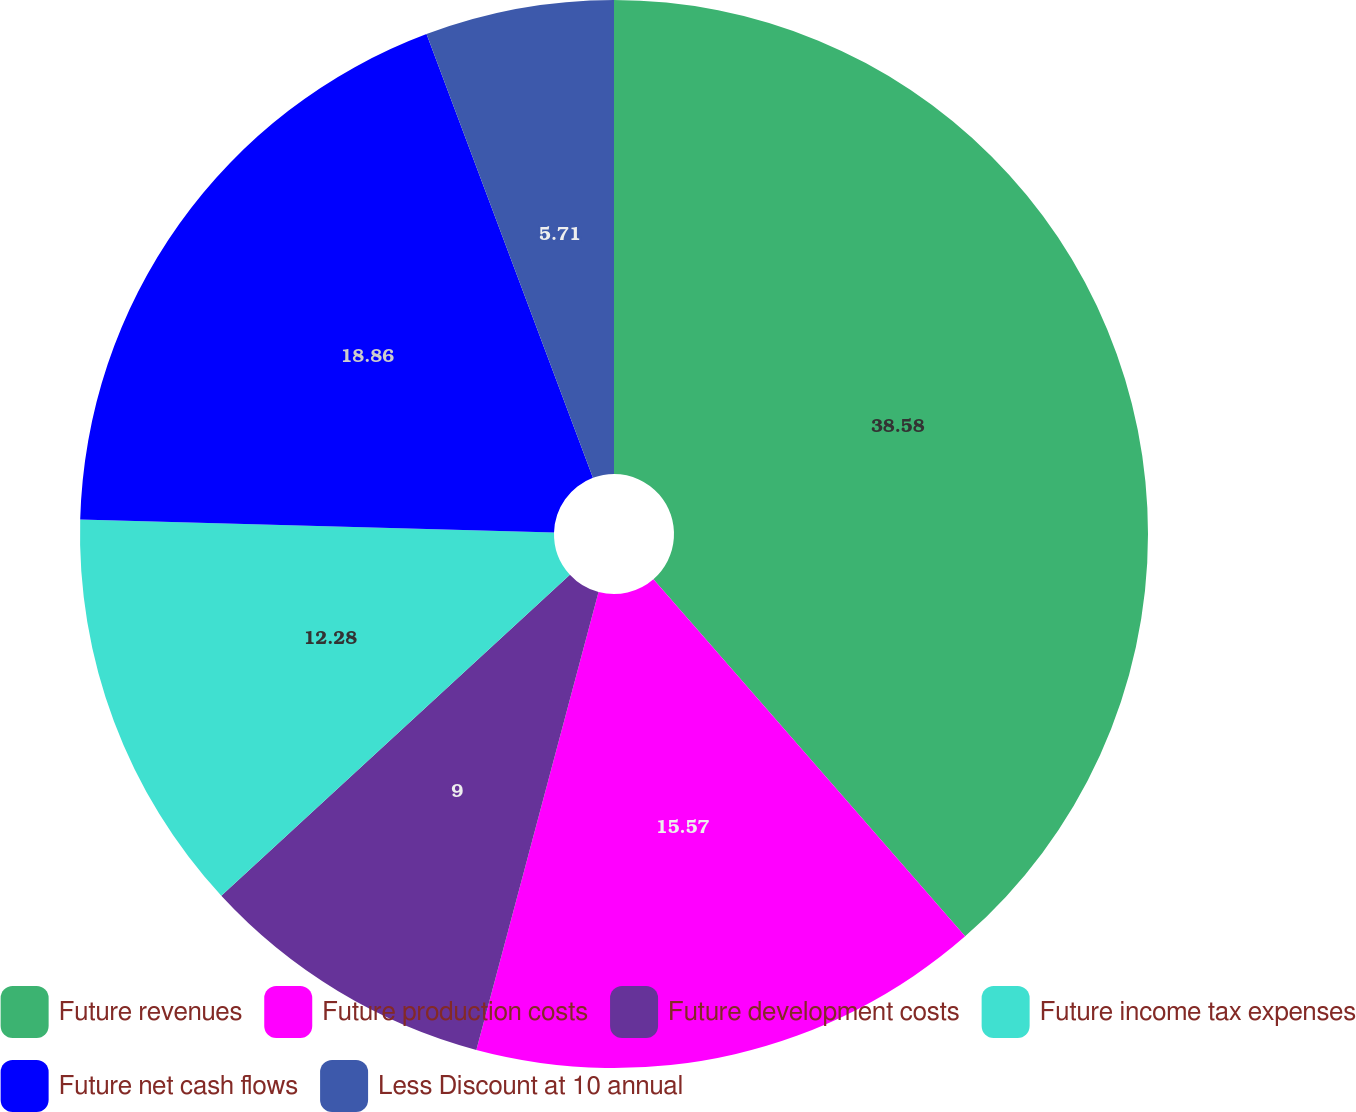<chart> <loc_0><loc_0><loc_500><loc_500><pie_chart><fcel>Future revenues<fcel>Future production costs<fcel>Future development costs<fcel>Future income tax expenses<fcel>Future net cash flows<fcel>Less Discount at 10 annual<nl><fcel>38.58%<fcel>15.57%<fcel>9.0%<fcel>12.28%<fcel>18.86%<fcel>5.71%<nl></chart> 